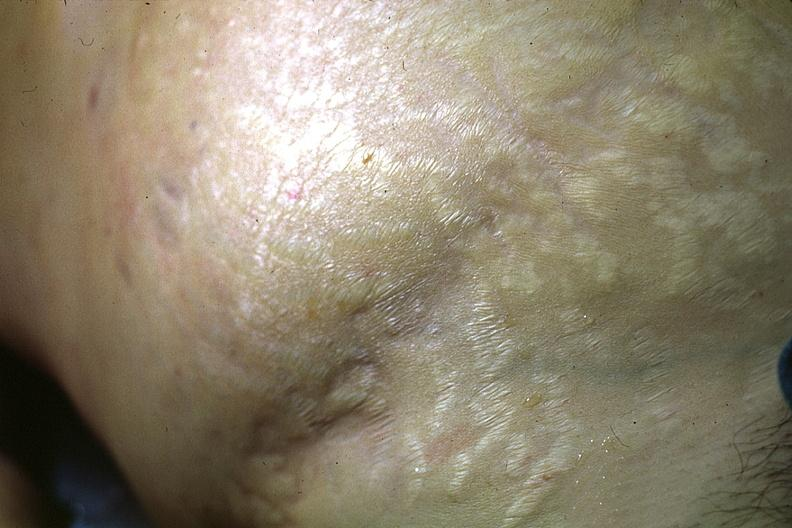does this image show good abdominal stria?
Answer the question using a single word or phrase. Yes 